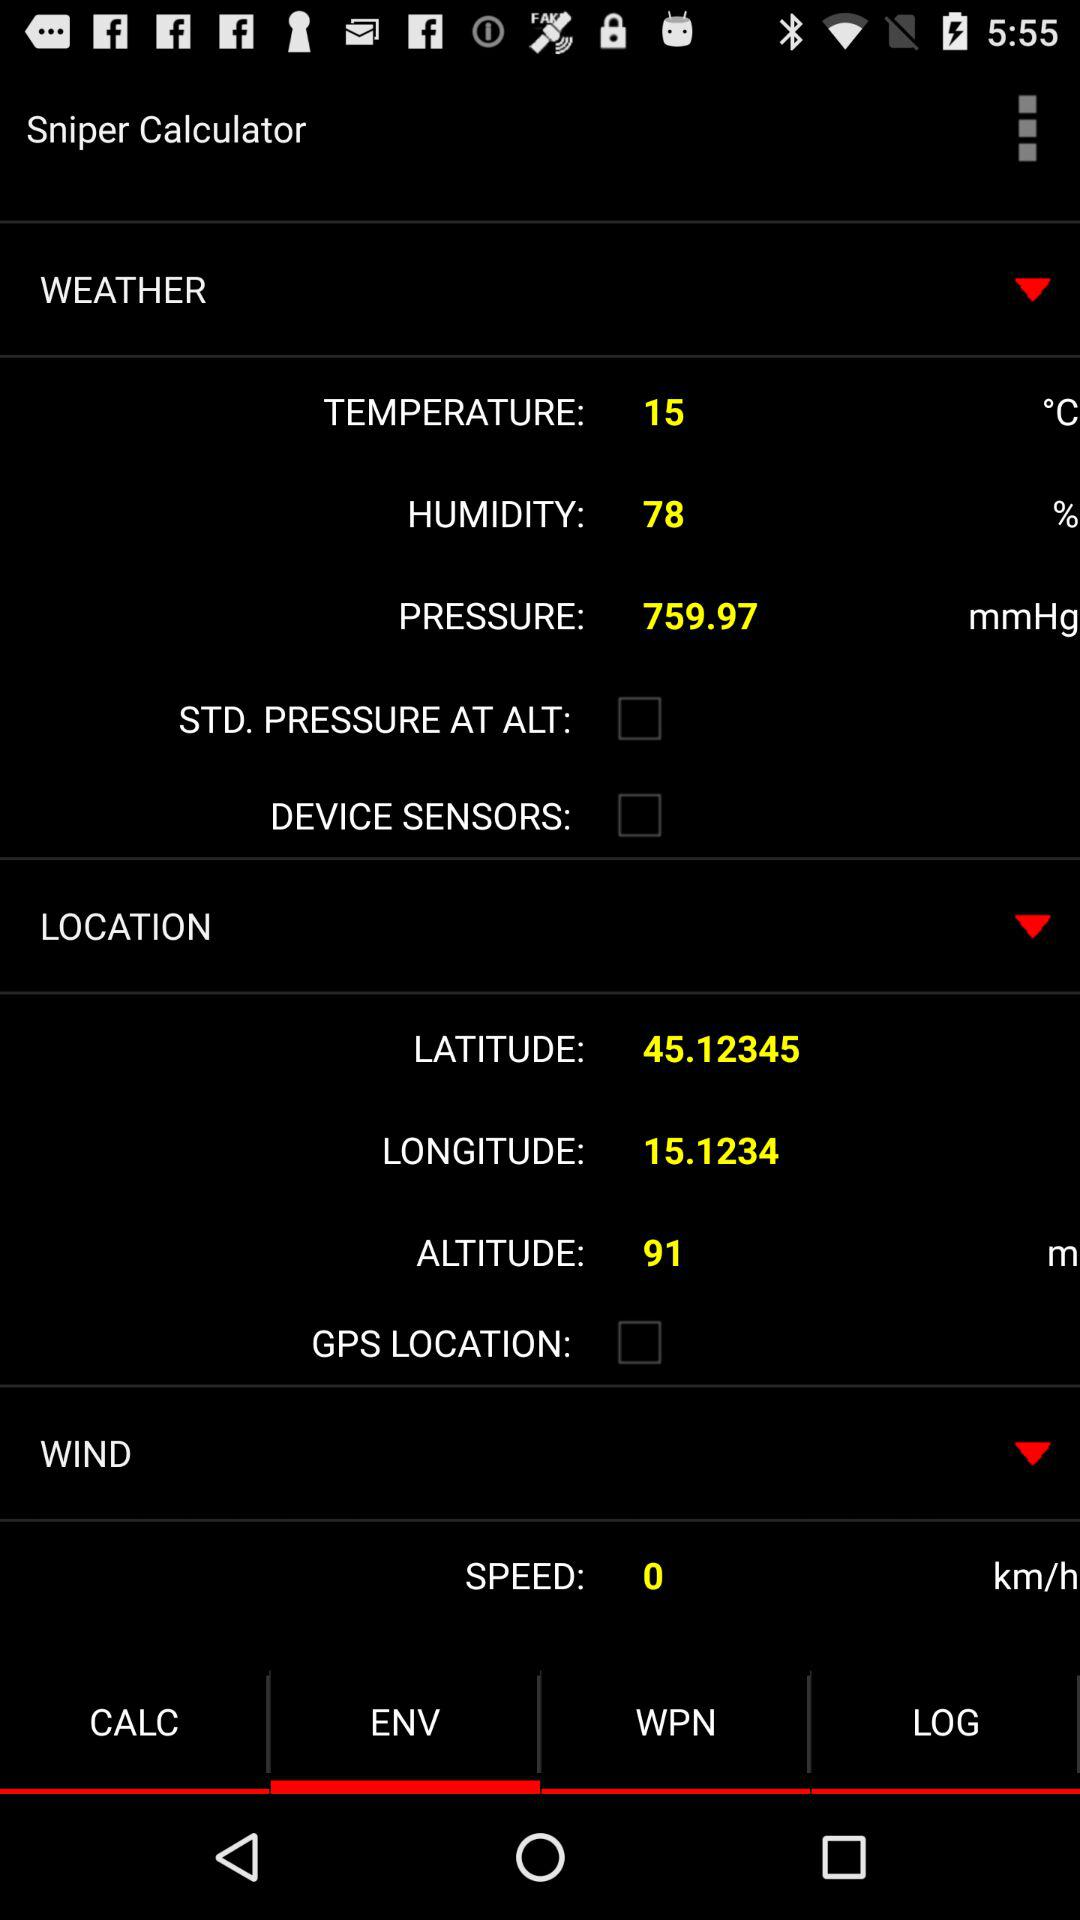What is the temperature? The temperature is 15 °C. 